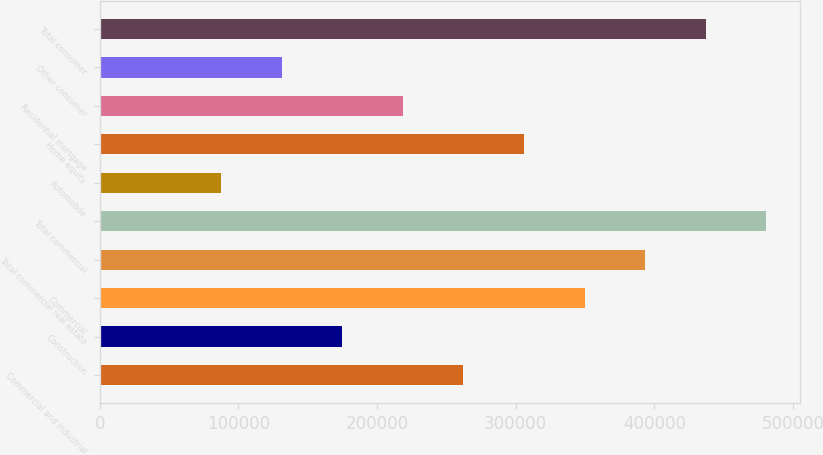<chart> <loc_0><loc_0><loc_500><loc_500><bar_chart><fcel>Commercial and industrial<fcel>Construction<fcel>Commercial<fcel>Total commercial real estate<fcel>Total commercial<fcel>Automobile<fcel>Home equity<fcel>Residential mortgage<fcel>Other consumer<fcel>Total consumer<nl><fcel>262254<fcel>174836<fcel>349671<fcel>393380<fcel>480798<fcel>87418.7<fcel>305963<fcel>218545<fcel>131127<fcel>437089<nl></chart> 